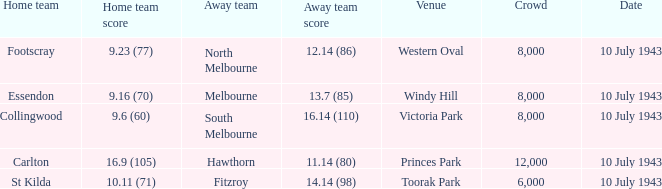What was the score for carlton's home team when they played? 16.9 (105). 